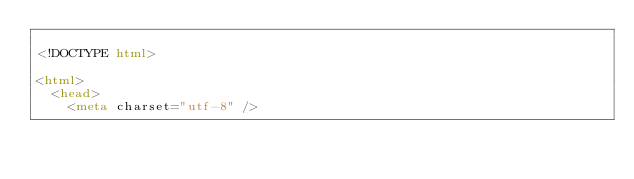Convert code to text. <code><loc_0><loc_0><loc_500><loc_500><_HTML_>
<!DOCTYPE html>

<html>
  <head>
    <meta charset="utf-8" /></code> 